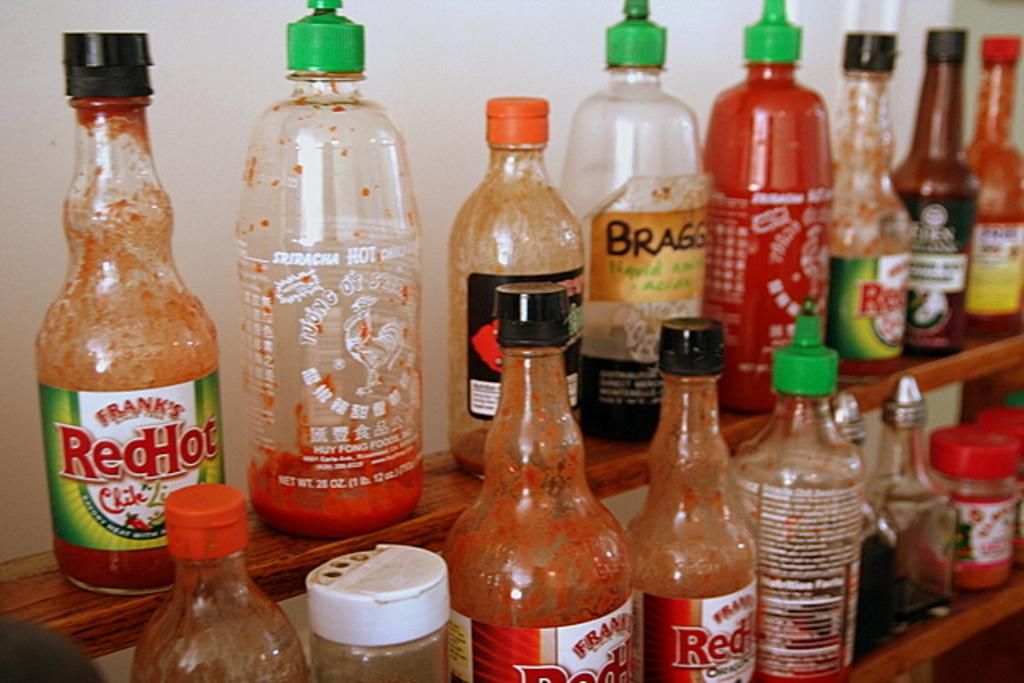<image>
Summarize the visual content of the image. Several used bottles of hot sauce one being Frank's Red Hot. 